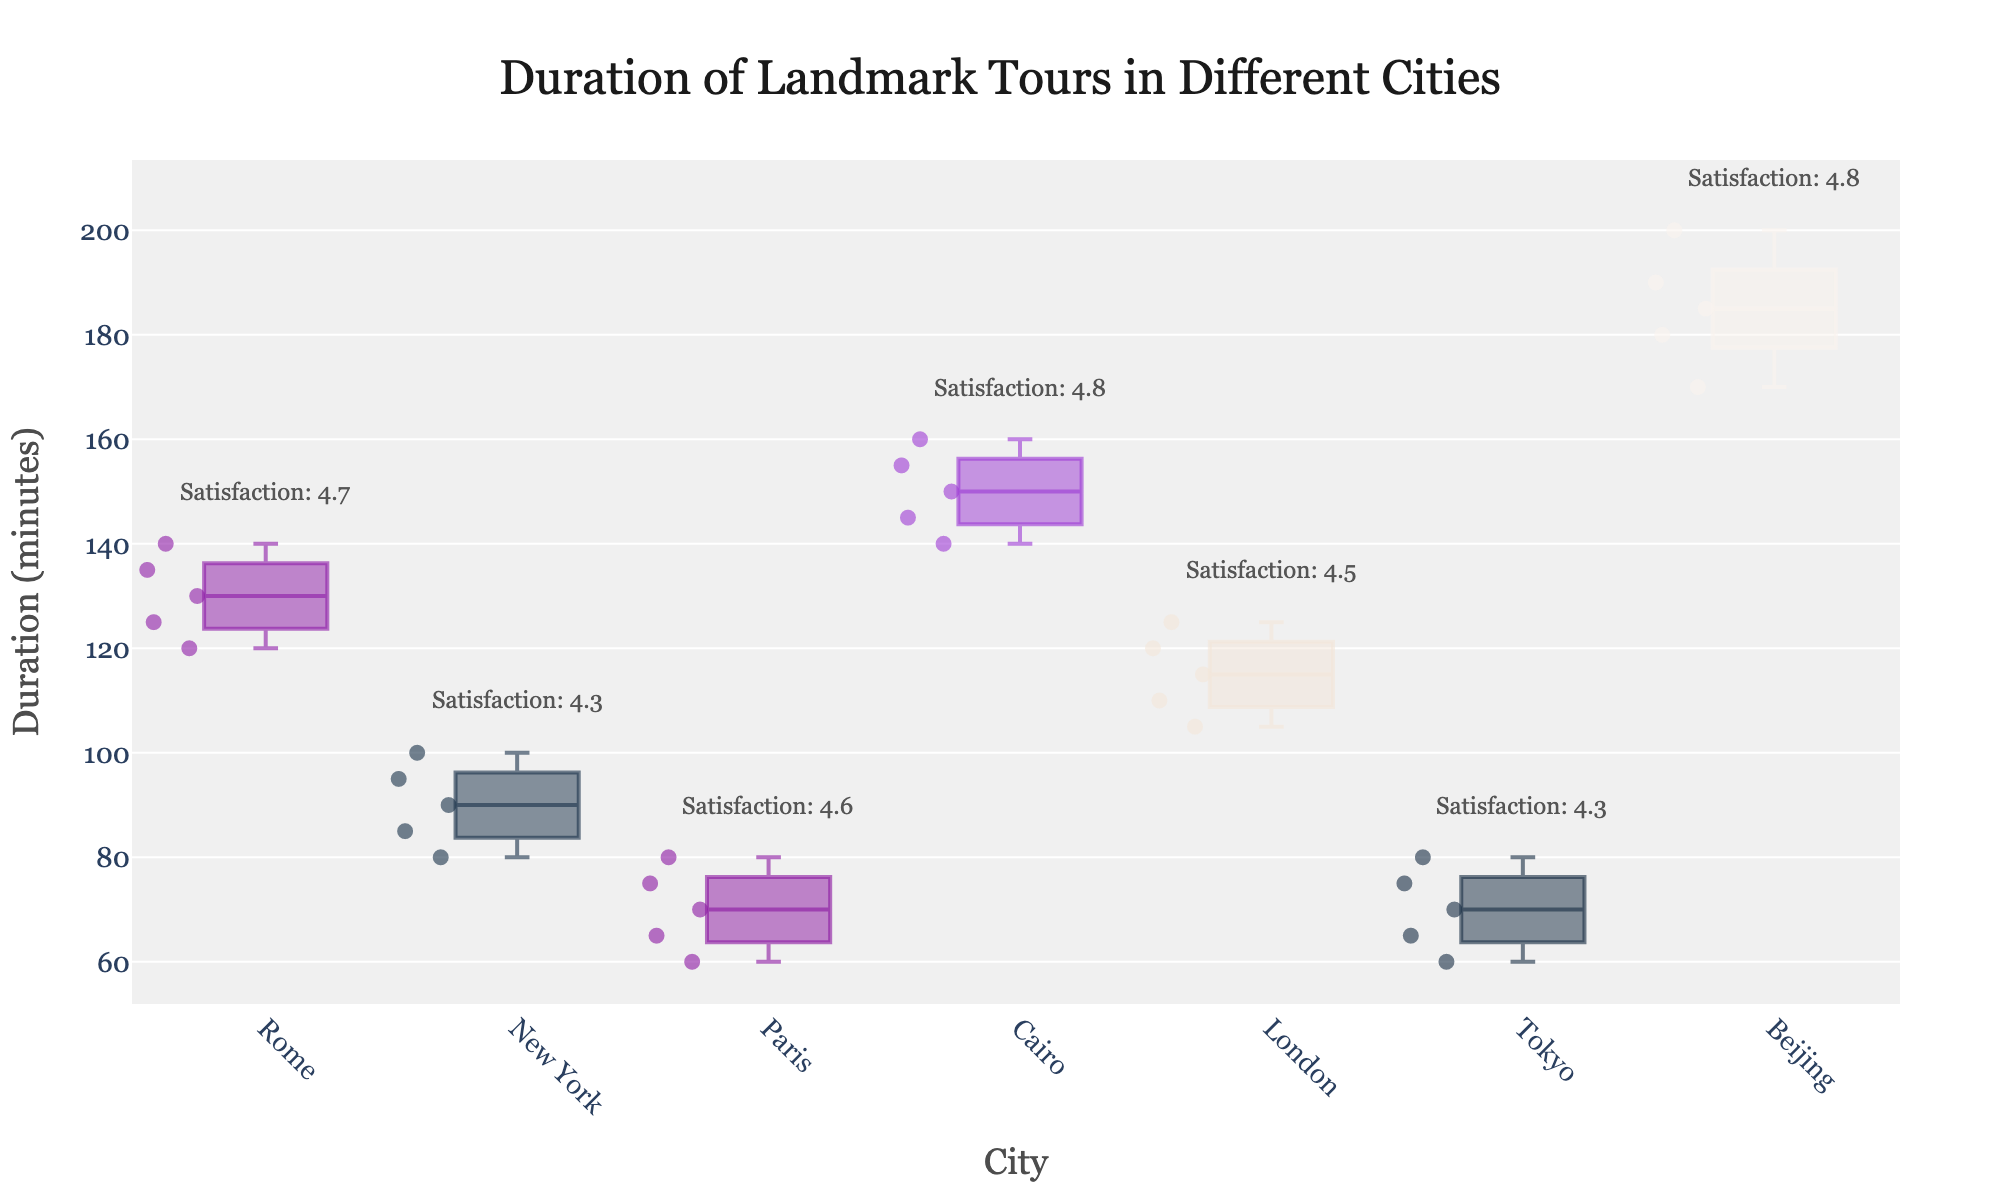What is the title of the plot? The title of the plot is displayed at the top and center of the figure. It reads "Duration of Landmark Tours in Different Cities."
Answer: Duration of Landmark Tours in Different Cities Which city has the shortest median tour duration? Look at the median line within the boxes; the city with the lowest median line represents the shortest median tour duration. The city is Paris, as its median line is lower than others.
Answer: Paris What is the average visitor satisfaction rating in Cairo? Find Cairo on the x-axis and look at the annotation above it. The text shows the average satisfaction rating for the city. It reads "Satisfaction: 4.8".
Answer: 4.8 Which city has the widest range of tour durations? The widest range can be observed by comparing the lengths of the boxes (interquartile range) and whiskers on the y-axis. Beijing has the widest range with tour durations spread between 170 and 200 minutes.
Answer: Beijing How does the median tour duration of New York compare to that of London? Compare the median lines within the boxes for New York and London. The median of New York (90 mins) is less than that of London (115 mins).
Answer: New York's median is less Which city’s tours have the least variability in duration? The city with the least variability will have the smallest interquartile range, observed by the height of the box. Paris has the smallest box, indicating the least variability.
Answer: Paris How do the satisfaction ratings of Rome compare to those of Paris? Compare the average satisfaction ratings annotated above both cities. Rome has a "Satisfaction: 4.7" while Paris has a "Satisfaction: 4.6."
Answer: Rome's satisfaction is higher What is the duration range of tours for the Great Pyramid of Giza in Cairo? Look at the top and bottom ends of the whiskers for Cairo. The range spans from 140 minutes to 160 minutes.
Answer: 140 to 160 minutes What is the interquartile range (IQR) for tours in Tokyo? The interquartile range is the difference between the upper and lower quartiles of the box for Tokyo. The 75th percentile is around 75 minutes and the 25th percentile is around 65 minutes, giving an IQR of 75 - 65.
Answer: 10 minutes 